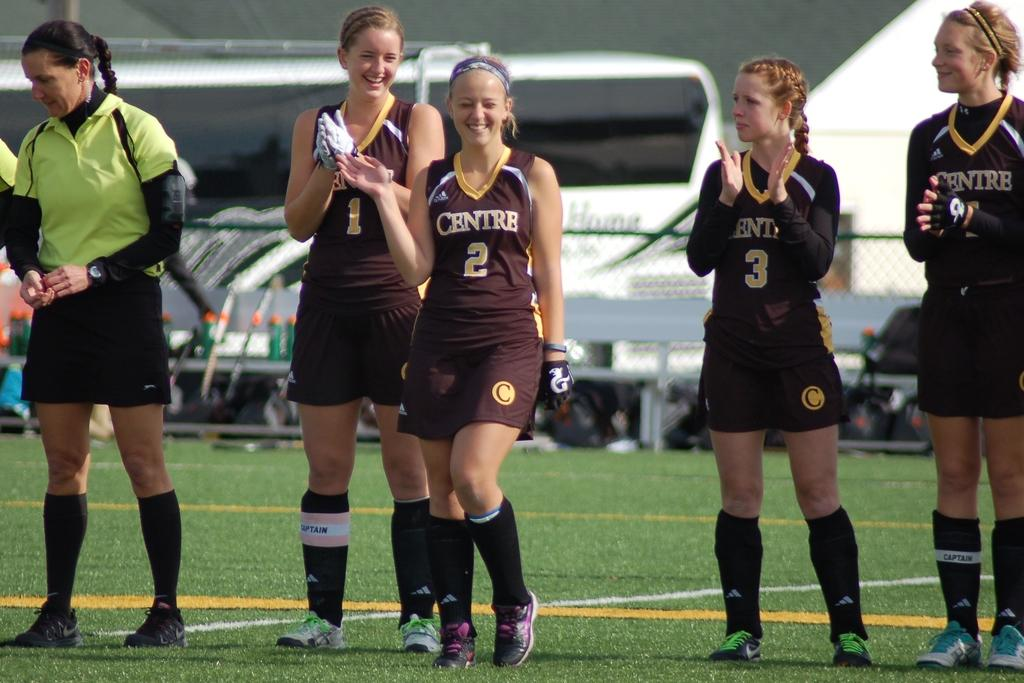What is happening in the image involving the group of people? The people in the image are standing and clapping their hands. What are the people wearing in the image? The people are wearing the same type of dress. What is visible in the foreground of the image? There is grass visible in the foreground of the image. What type of rake is being used by the people in the image? There is no rake present in the image; the people are standing and clapping their hands. How many days have passed since the event in the image took place? The provided facts do not give any information about the timing of the event, so it is impossible to determine how many days have passed since it occurred. 